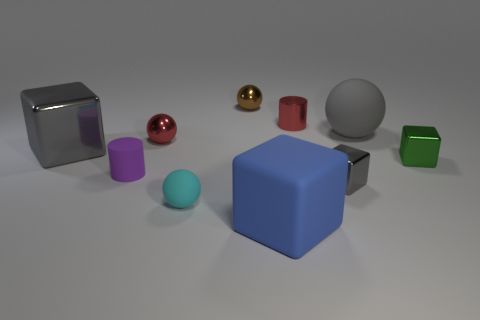Subtract all purple balls. How many gray cubes are left? 2 Subtract all small green metallic cubes. How many cubes are left? 3 Subtract all blue cubes. How many cubes are left? 3 Subtract all yellow cubes. Subtract all gray spheres. How many cubes are left? 4 Subtract all cubes. How many objects are left? 6 Subtract all tiny green metal blocks. Subtract all big gray matte things. How many objects are left? 8 Add 5 red things. How many red things are left? 7 Add 2 yellow metallic cubes. How many yellow metallic cubes exist? 2 Subtract 0 cyan cylinders. How many objects are left? 10 